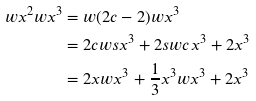<formula> <loc_0><loc_0><loc_500><loc_500>w x ^ { 2 } w x ^ { 3 } & = w ( 2 c - 2 ) w x ^ { 3 } \\ & = 2 c w s x ^ { 3 } + 2 s w c x ^ { 3 } + 2 x ^ { 3 } \\ & = 2 x w x ^ { 3 } + \frac { 1 } { 3 } x ^ { 3 } w x ^ { 3 } + 2 x ^ { 3 }</formula> 